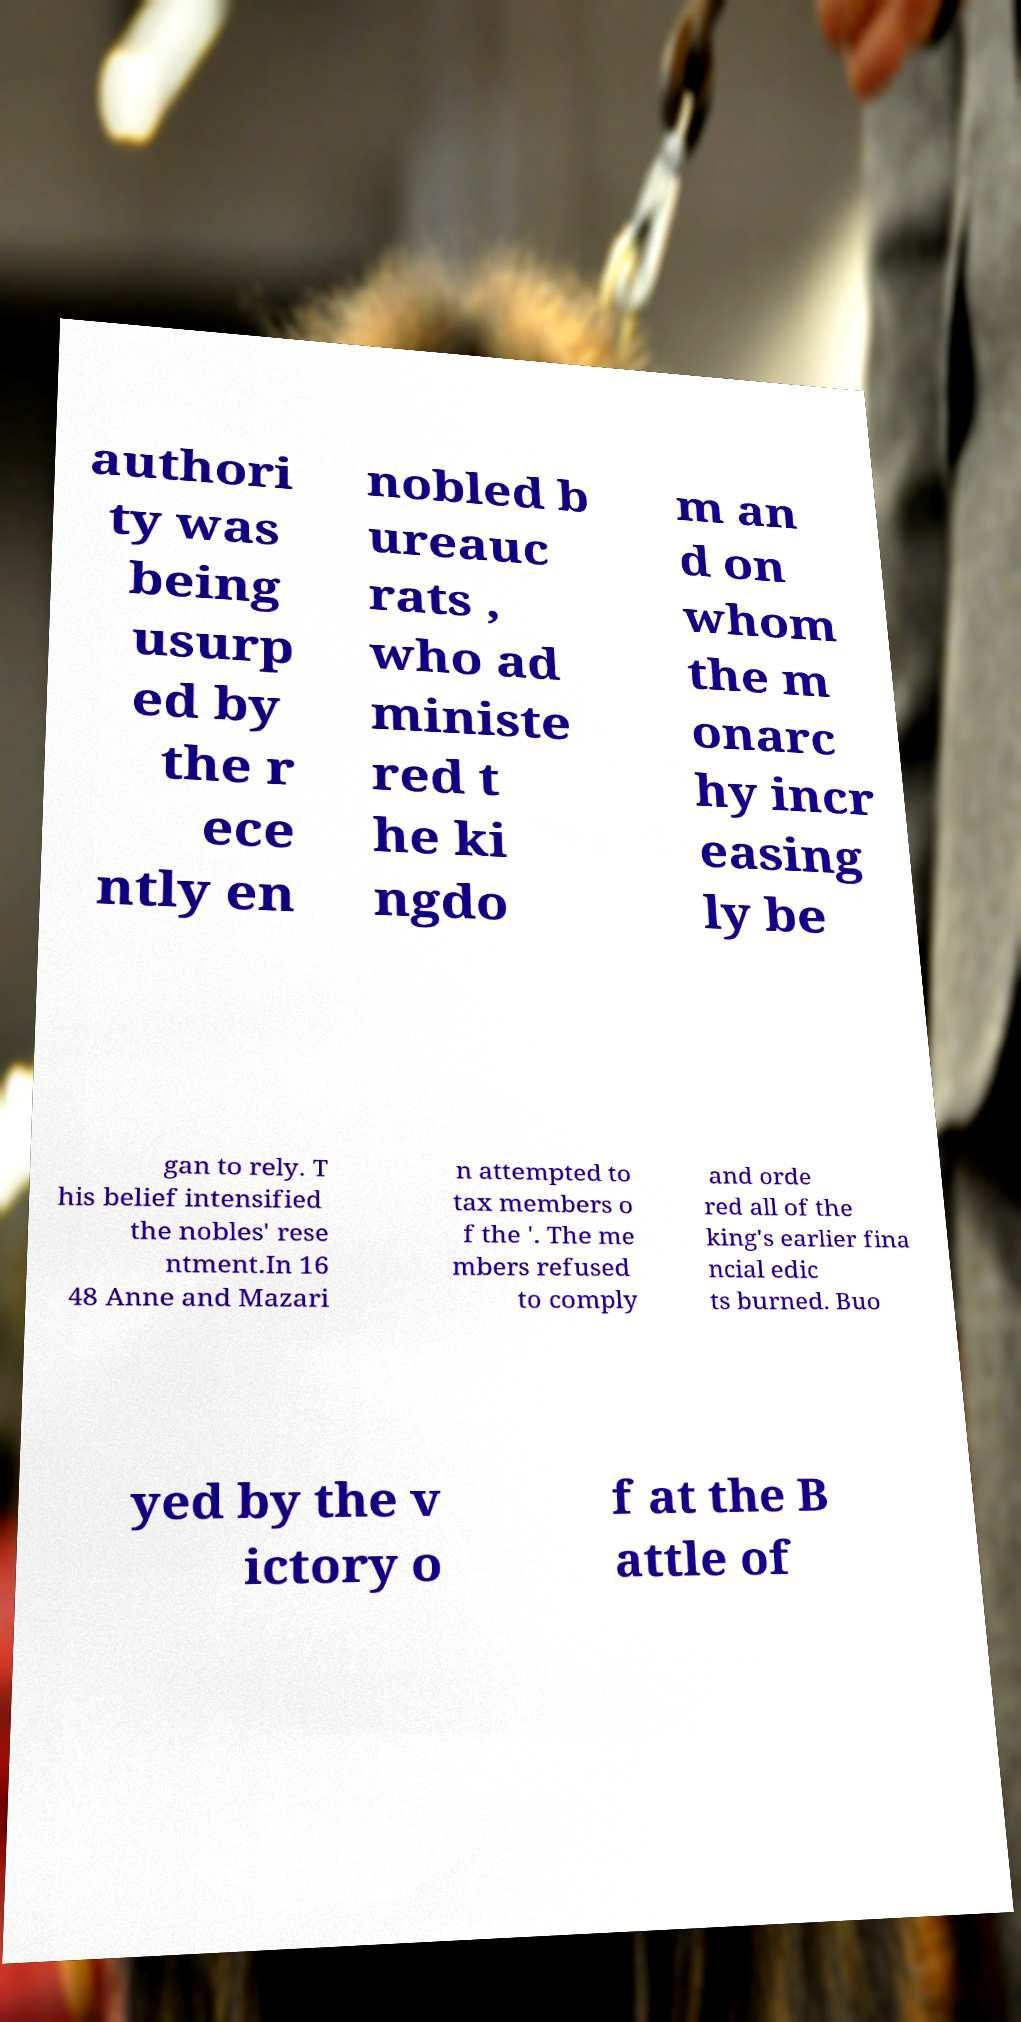Could you extract and type out the text from this image? authori ty was being usurp ed by the r ece ntly en nobled b ureauc rats , who ad ministe red t he ki ngdo m an d on whom the m onarc hy incr easing ly be gan to rely. T his belief intensified the nobles' rese ntment.In 16 48 Anne and Mazari n attempted to tax members o f the '. The me mbers refused to comply and orde red all of the king's earlier fina ncial edic ts burned. Buo yed by the v ictory o f at the B attle of 